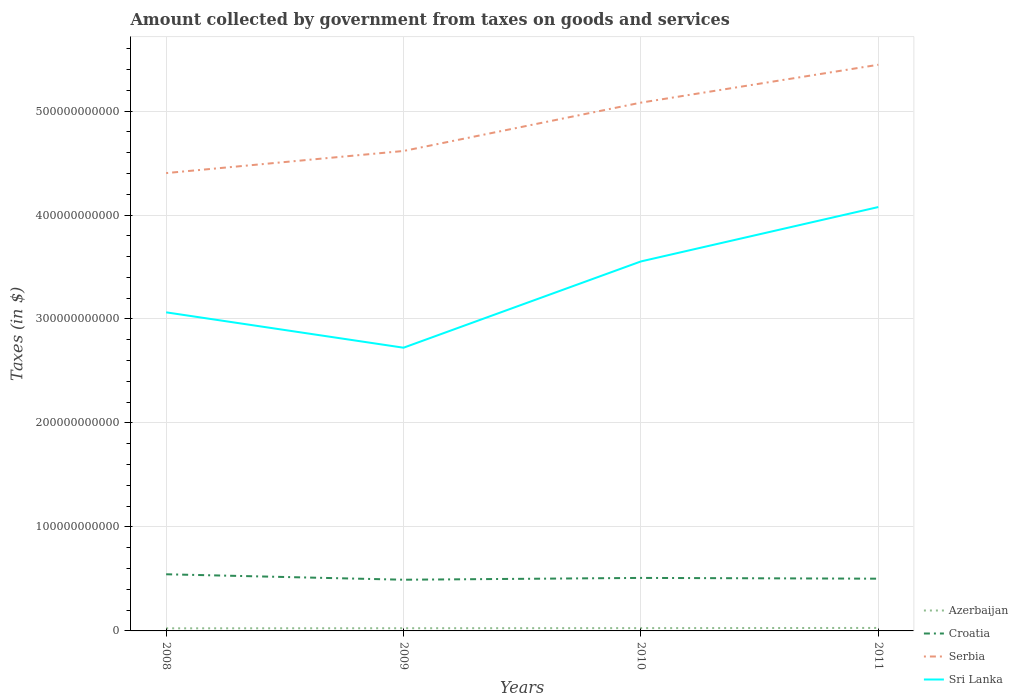How many different coloured lines are there?
Provide a succinct answer. 4. Is the number of lines equal to the number of legend labels?
Offer a terse response. Yes. Across all years, what is the maximum amount collected by government from taxes on goods and services in Croatia?
Ensure brevity in your answer.  4.92e+1. What is the total amount collected by government from taxes on goods and services in Sri Lanka in the graph?
Your answer should be compact. -1.01e+11. What is the difference between the highest and the second highest amount collected by government from taxes on goods and services in Sri Lanka?
Your answer should be very brief. 1.35e+11. Is the amount collected by government from taxes on goods and services in Serbia strictly greater than the amount collected by government from taxes on goods and services in Croatia over the years?
Provide a short and direct response. No. How many lines are there?
Ensure brevity in your answer.  4. How many years are there in the graph?
Provide a succinct answer. 4. What is the difference between two consecutive major ticks on the Y-axis?
Your answer should be compact. 1.00e+11. Are the values on the major ticks of Y-axis written in scientific E-notation?
Your answer should be very brief. No. Does the graph contain any zero values?
Make the answer very short. No. Where does the legend appear in the graph?
Give a very brief answer. Bottom right. How many legend labels are there?
Make the answer very short. 4. What is the title of the graph?
Your answer should be very brief. Amount collected by government from taxes on goods and services. Does "Somalia" appear as one of the legend labels in the graph?
Offer a very short reply. No. What is the label or title of the Y-axis?
Keep it short and to the point. Taxes (in $). What is the Taxes (in $) of Azerbaijan in 2008?
Your response must be concise. 2.50e+09. What is the Taxes (in $) in Croatia in 2008?
Provide a succinct answer. 5.45e+1. What is the Taxes (in $) in Serbia in 2008?
Keep it short and to the point. 4.40e+11. What is the Taxes (in $) in Sri Lanka in 2008?
Your response must be concise. 3.06e+11. What is the Taxes (in $) in Azerbaijan in 2009?
Your response must be concise. 2.59e+09. What is the Taxes (in $) in Croatia in 2009?
Make the answer very short. 4.92e+1. What is the Taxes (in $) of Serbia in 2009?
Provide a short and direct response. 4.62e+11. What is the Taxes (in $) of Sri Lanka in 2009?
Make the answer very short. 2.72e+11. What is the Taxes (in $) of Azerbaijan in 2010?
Provide a succinct answer. 2.70e+09. What is the Taxes (in $) of Croatia in 2010?
Provide a short and direct response. 5.10e+1. What is the Taxes (in $) of Serbia in 2010?
Your response must be concise. 5.08e+11. What is the Taxes (in $) of Sri Lanka in 2010?
Your answer should be very brief. 3.55e+11. What is the Taxes (in $) of Azerbaijan in 2011?
Offer a terse response. 2.87e+09. What is the Taxes (in $) of Croatia in 2011?
Offer a terse response. 5.02e+1. What is the Taxes (in $) in Serbia in 2011?
Provide a succinct answer. 5.45e+11. What is the Taxes (in $) in Sri Lanka in 2011?
Provide a succinct answer. 4.08e+11. Across all years, what is the maximum Taxes (in $) in Azerbaijan?
Your response must be concise. 2.87e+09. Across all years, what is the maximum Taxes (in $) in Croatia?
Offer a very short reply. 5.45e+1. Across all years, what is the maximum Taxes (in $) in Serbia?
Give a very brief answer. 5.45e+11. Across all years, what is the maximum Taxes (in $) in Sri Lanka?
Offer a very short reply. 4.08e+11. Across all years, what is the minimum Taxes (in $) of Azerbaijan?
Keep it short and to the point. 2.50e+09. Across all years, what is the minimum Taxes (in $) in Croatia?
Offer a very short reply. 4.92e+1. Across all years, what is the minimum Taxes (in $) of Serbia?
Your answer should be compact. 4.40e+11. Across all years, what is the minimum Taxes (in $) in Sri Lanka?
Provide a short and direct response. 2.72e+11. What is the total Taxes (in $) of Azerbaijan in the graph?
Make the answer very short. 1.07e+1. What is the total Taxes (in $) in Croatia in the graph?
Give a very brief answer. 2.05e+11. What is the total Taxes (in $) of Serbia in the graph?
Provide a short and direct response. 1.95e+12. What is the total Taxes (in $) of Sri Lanka in the graph?
Your answer should be very brief. 1.34e+12. What is the difference between the Taxes (in $) in Azerbaijan in 2008 and that in 2009?
Give a very brief answer. -9.02e+07. What is the difference between the Taxes (in $) in Croatia in 2008 and that in 2009?
Ensure brevity in your answer.  5.24e+09. What is the difference between the Taxes (in $) in Serbia in 2008 and that in 2009?
Keep it short and to the point. -2.13e+1. What is the difference between the Taxes (in $) of Sri Lanka in 2008 and that in 2009?
Make the answer very short. 3.40e+1. What is the difference between the Taxes (in $) in Azerbaijan in 2008 and that in 2010?
Ensure brevity in your answer.  -1.93e+08. What is the difference between the Taxes (in $) in Croatia in 2008 and that in 2010?
Give a very brief answer. 3.50e+09. What is the difference between the Taxes (in $) in Serbia in 2008 and that in 2010?
Provide a short and direct response. -6.78e+1. What is the difference between the Taxes (in $) in Sri Lanka in 2008 and that in 2010?
Provide a succinct answer. -4.90e+1. What is the difference between the Taxes (in $) of Azerbaijan in 2008 and that in 2011?
Offer a very short reply. -3.62e+08. What is the difference between the Taxes (in $) of Croatia in 2008 and that in 2011?
Provide a succinct answer. 4.24e+09. What is the difference between the Taxes (in $) in Serbia in 2008 and that in 2011?
Offer a very short reply. -1.04e+11. What is the difference between the Taxes (in $) in Sri Lanka in 2008 and that in 2011?
Your answer should be compact. -1.01e+11. What is the difference between the Taxes (in $) of Azerbaijan in 2009 and that in 2010?
Offer a terse response. -1.03e+08. What is the difference between the Taxes (in $) of Croatia in 2009 and that in 2010?
Offer a very short reply. -1.74e+09. What is the difference between the Taxes (in $) in Serbia in 2009 and that in 2010?
Ensure brevity in your answer.  -4.65e+1. What is the difference between the Taxes (in $) of Sri Lanka in 2009 and that in 2010?
Ensure brevity in your answer.  -8.30e+1. What is the difference between the Taxes (in $) in Azerbaijan in 2009 and that in 2011?
Your response must be concise. -2.72e+08. What is the difference between the Taxes (in $) of Croatia in 2009 and that in 2011?
Make the answer very short. -1.01e+09. What is the difference between the Taxes (in $) in Serbia in 2009 and that in 2011?
Offer a very short reply. -8.29e+1. What is the difference between the Taxes (in $) of Sri Lanka in 2009 and that in 2011?
Keep it short and to the point. -1.35e+11. What is the difference between the Taxes (in $) of Azerbaijan in 2010 and that in 2011?
Your answer should be very brief. -1.70e+08. What is the difference between the Taxes (in $) in Croatia in 2010 and that in 2011?
Provide a succinct answer. 7.36e+08. What is the difference between the Taxes (in $) of Serbia in 2010 and that in 2011?
Offer a terse response. -3.64e+1. What is the difference between the Taxes (in $) in Sri Lanka in 2010 and that in 2011?
Your answer should be very brief. -5.23e+1. What is the difference between the Taxes (in $) in Azerbaijan in 2008 and the Taxes (in $) in Croatia in 2009?
Your answer should be compact. -4.67e+1. What is the difference between the Taxes (in $) in Azerbaijan in 2008 and the Taxes (in $) in Serbia in 2009?
Your response must be concise. -4.59e+11. What is the difference between the Taxes (in $) of Azerbaijan in 2008 and the Taxes (in $) of Sri Lanka in 2009?
Keep it short and to the point. -2.70e+11. What is the difference between the Taxes (in $) of Croatia in 2008 and the Taxes (in $) of Serbia in 2009?
Keep it short and to the point. -4.07e+11. What is the difference between the Taxes (in $) of Croatia in 2008 and the Taxes (in $) of Sri Lanka in 2009?
Make the answer very short. -2.18e+11. What is the difference between the Taxes (in $) in Serbia in 2008 and the Taxes (in $) in Sri Lanka in 2009?
Give a very brief answer. 1.68e+11. What is the difference between the Taxes (in $) of Azerbaijan in 2008 and the Taxes (in $) of Croatia in 2010?
Make the answer very short. -4.85e+1. What is the difference between the Taxes (in $) in Azerbaijan in 2008 and the Taxes (in $) in Serbia in 2010?
Offer a terse response. -5.06e+11. What is the difference between the Taxes (in $) of Azerbaijan in 2008 and the Taxes (in $) of Sri Lanka in 2010?
Give a very brief answer. -3.53e+11. What is the difference between the Taxes (in $) of Croatia in 2008 and the Taxes (in $) of Serbia in 2010?
Ensure brevity in your answer.  -4.54e+11. What is the difference between the Taxes (in $) of Croatia in 2008 and the Taxes (in $) of Sri Lanka in 2010?
Your response must be concise. -3.01e+11. What is the difference between the Taxes (in $) of Serbia in 2008 and the Taxes (in $) of Sri Lanka in 2010?
Give a very brief answer. 8.50e+1. What is the difference between the Taxes (in $) in Azerbaijan in 2008 and the Taxes (in $) in Croatia in 2011?
Your answer should be very brief. -4.77e+1. What is the difference between the Taxes (in $) in Azerbaijan in 2008 and the Taxes (in $) in Serbia in 2011?
Provide a succinct answer. -5.42e+11. What is the difference between the Taxes (in $) in Azerbaijan in 2008 and the Taxes (in $) in Sri Lanka in 2011?
Provide a succinct answer. -4.05e+11. What is the difference between the Taxes (in $) in Croatia in 2008 and the Taxes (in $) in Serbia in 2011?
Give a very brief answer. -4.90e+11. What is the difference between the Taxes (in $) of Croatia in 2008 and the Taxes (in $) of Sri Lanka in 2011?
Your answer should be compact. -3.53e+11. What is the difference between the Taxes (in $) of Serbia in 2008 and the Taxes (in $) of Sri Lanka in 2011?
Your answer should be very brief. 3.27e+1. What is the difference between the Taxes (in $) in Azerbaijan in 2009 and the Taxes (in $) in Croatia in 2010?
Keep it short and to the point. -4.84e+1. What is the difference between the Taxes (in $) in Azerbaijan in 2009 and the Taxes (in $) in Serbia in 2010?
Make the answer very short. -5.06e+11. What is the difference between the Taxes (in $) in Azerbaijan in 2009 and the Taxes (in $) in Sri Lanka in 2010?
Provide a succinct answer. -3.53e+11. What is the difference between the Taxes (in $) in Croatia in 2009 and the Taxes (in $) in Serbia in 2010?
Give a very brief answer. -4.59e+11. What is the difference between the Taxes (in $) of Croatia in 2009 and the Taxes (in $) of Sri Lanka in 2010?
Keep it short and to the point. -3.06e+11. What is the difference between the Taxes (in $) in Serbia in 2009 and the Taxes (in $) in Sri Lanka in 2010?
Offer a very short reply. 1.06e+11. What is the difference between the Taxes (in $) in Azerbaijan in 2009 and the Taxes (in $) in Croatia in 2011?
Your answer should be very brief. -4.77e+1. What is the difference between the Taxes (in $) in Azerbaijan in 2009 and the Taxes (in $) in Serbia in 2011?
Offer a very short reply. -5.42e+11. What is the difference between the Taxes (in $) of Azerbaijan in 2009 and the Taxes (in $) of Sri Lanka in 2011?
Your answer should be compact. -4.05e+11. What is the difference between the Taxes (in $) in Croatia in 2009 and the Taxes (in $) in Serbia in 2011?
Offer a very short reply. -4.95e+11. What is the difference between the Taxes (in $) in Croatia in 2009 and the Taxes (in $) in Sri Lanka in 2011?
Keep it short and to the point. -3.58e+11. What is the difference between the Taxes (in $) in Serbia in 2009 and the Taxes (in $) in Sri Lanka in 2011?
Ensure brevity in your answer.  5.39e+1. What is the difference between the Taxes (in $) in Azerbaijan in 2010 and the Taxes (in $) in Croatia in 2011?
Make the answer very short. -4.75e+1. What is the difference between the Taxes (in $) of Azerbaijan in 2010 and the Taxes (in $) of Serbia in 2011?
Your answer should be very brief. -5.42e+11. What is the difference between the Taxes (in $) of Azerbaijan in 2010 and the Taxes (in $) of Sri Lanka in 2011?
Provide a short and direct response. -4.05e+11. What is the difference between the Taxes (in $) of Croatia in 2010 and the Taxes (in $) of Serbia in 2011?
Ensure brevity in your answer.  -4.94e+11. What is the difference between the Taxes (in $) in Croatia in 2010 and the Taxes (in $) in Sri Lanka in 2011?
Provide a succinct answer. -3.57e+11. What is the difference between the Taxes (in $) of Serbia in 2010 and the Taxes (in $) of Sri Lanka in 2011?
Make the answer very short. 1.00e+11. What is the average Taxes (in $) in Azerbaijan per year?
Your answer should be compact. 2.66e+09. What is the average Taxes (in $) in Croatia per year?
Your response must be concise. 5.12e+1. What is the average Taxes (in $) of Serbia per year?
Offer a terse response. 4.89e+11. What is the average Taxes (in $) of Sri Lanka per year?
Offer a very short reply. 3.35e+11. In the year 2008, what is the difference between the Taxes (in $) in Azerbaijan and Taxes (in $) in Croatia?
Your answer should be compact. -5.20e+1. In the year 2008, what is the difference between the Taxes (in $) in Azerbaijan and Taxes (in $) in Serbia?
Keep it short and to the point. -4.38e+11. In the year 2008, what is the difference between the Taxes (in $) in Azerbaijan and Taxes (in $) in Sri Lanka?
Offer a very short reply. -3.04e+11. In the year 2008, what is the difference between the Taxes (in $) of Croatia and Taxes (in $) of Serbia?
Give a very brief answer. -3.86e+11. In the year 2008, what is the difference between the Taxes (in $) of Croatia and Taxes (in $) of Sri Lanka?
Your answer should be very brief. -2.52e+11. In the year 2008, what is the difference between the Taxes (in $) in Serbia and Taxes (in $) in Sri Lanka?
Provide a short and direct response. 1.34e+11. In the year 2009, what is the difference between the Taxes (in $) of Azerbaijan and Taxes (in $) of Croatia?
Keep it short and to the point. -4.66e+1. In the year 2009, what is the difference between the Taxes (in $) in Azerbaijan and Taxes (in $) in Serbia?
Offer a terse response. -4.59e+11. In the year 2009, what is the difference between the Taxes (in $) of Azerbaijan and Taxes (in $) of Sri Lanka?
Your response must be concise. -2.70e+11. In the year 2009, what is the difference between the Taxes (in $) of Croatia and Taxes (in $) of Serbia?
Your answer should be compact. -4.12e+11. In the year 2009, what is the difference between the Taxes (in $) of Croatia and Taxes (in $) of Sri Lanka?
Your response must be concise. -2.23e+11. In the year 2009, what is the difference between the Taxes (in $) in Serbia and Taxes (in $) in Sri Lanka?
Your response must be concise. 1.89e+11. In the year 2010, what is the difference between the Taxes (in $) of Azerbaijan and Taxes (in $) of Croatia?
Provide a short and direct response. -4.83e+1. In the year 2010, what is the difference between the Taxes (in $) in Azerbaijan and Taxes (in $) in Serbia?
Offer a very short reply. -5.05e+11. In the year 2010, what is the difference between the Taxes (in $) of Azerbaijan and Taxes (in $) of Sri Lanka?
Provide a succinct answer. -3.53e+11. In the year 2010, what is the difference between the Taxes (in $) of Croatia and Taxes (in $) of Serbia?
Make the answer very short. -4.57e+11. In the year 2010, what is the difference between the Taxes (in $) in Croatia and Taxes (in $) in Sri Lanka?
Ensure brevity in your answer.  -3.04e+11. In the year 2010, what is the difference between the Taxes (in $) of Serbia and Taxes (in $) of Sri Lanka?
Your answer should be compact. 1.53e+11. In the year 2011, what is the difference between the Taxes (in $) in Azerbaijan and Taxes (in $) in Croatia?
Provide a succinct answer. -4.74e+1. In the year 2011, what is the difference between the Taxes (in $) in Azerbaijan and Taxes (in $) in Serbia?
Provide a succinct answer. -5.42e+11. In the year 2011, what is the difference between the Taxes (in $) of Azerbaijan and Taxes (in $) of Sri Lanka?
Your answer should be compact. -4.05e+11. In the year 2011, what is the difference between the Taxes (in $) of Croatia and Taxes (in $) of Serbia?
Your answer should be compact. -4.94e+11. In the year 2011, what is the difference between the Taxes (in $) in Croatia and Taxes (in $) in Sri Lanka?
Your answer should be very brief. -3.57e+11. In the year 2011, what is the difference between the Taxes (in $) of Serbia and Taxes (in $) of Sri Lanka?
Offer a terse response. 1.37e+11. What is the ratio of the Taxes (in $) in Azerbaijan in 2008 to that in 2009?
Your answer should be compact. 0.97. What is the ratio of the Taxes (in $) in Croatia in 2008 to that in 2009?
Provide a succinct answer. 1.11. What is the ratio of the Taxes (in $) in Serbia in 2008 to that in 2009?
Your response must be concise. 0.95. What is the ratio of the Taxes (in $) in Sri Lanka in 2008 to that in 2009?
Make the answer very short. 1.12. What is the ratio of the Taxes (in $) of Azerbaijan in 2008 to that in 2010?
Your answer should be very brief. 0.93. What is the ratio of the Taxes (in $) in Croatia in 2008 to that in 2010?
Ensure brevity in your answer.  1.07. What is the ratio of the Taxes (in $) of Serbia in 2008 to that in 2010?
Your response must be concise. 0.87. What is the ratio of the Taxes (in $) of Sri Lanka in 2008 to that in 2010?
Offer a terse response. 0.86. What is the ratio of the Taxes (in $) of Azerbaijan in 2008 to that in 2011?
Provide a succinct answer. 0.87. What is the ratio of the Taxes (in $) in Croatia in 2008 to that in 2011?
Provide a short and direct response. 1.08. What is the ratio of the Taxes (in $) in Serbia in 2008 to that in 2011?
Your response must be concise. 0.81. What is the ratio of the Taxes (in $) of Sri Lanka in 2008 to that in 2011?
Your answer should be very brief. 0.75. What is the ratio of the Taxes (in $) of Azerbaijan in 2009 to that in 2010?
Provide a short and direct response. 0.96. What is the ratio of the Taxes (in $) in Croatia in 2009 to that in 2010?
Your response must be concise. 0.97. What is the ratio of the Taxes (in $) in Serbia in 2009 to that in 2010?
Your answer should be compact. 0.91. What is the ratio of the Taxes (in $) of Sri Lanka in 2009 to that in 2010?
Give a very brief answer. 0.77. What is the ratio of the Taxes (in $) of Azerbaijan in 2009 to that in 2011?
Your answer should be compact. 0.91. What is the ratio of the Taxes (in $) in Croatia in 2009 to that in 2011?
Give a very brief answer. 0.98. What is the ratio of the Taxes (in $) of Serbia in 2009 to that in 2011?
Your answer should be compact. 0.85. What is the ratio of the Taxes (in $) of Sri Lanka in 2009 to that in 2011?
Your response must be concise. 0.67. What is the ratio of the Taxes (in $) in Azerbaijan in 2010 to that in 2011?
Offer a very short reply. 0.94. What is the ratio of the Taxes (in $) of Croatia in 2010 to that in 2011?
Provide a short and direct response. 1.01. What is the ratio of the Taxes (in $) of Serbia in 2010 to that in 2011?
Make the answer very short. 0.93. What is the ratio of the Taxes (in $) in Sri Lanka in 2010 to that in 2011?
Offer a very short reply. 0.87. What is the difference between the highest and the second highest Taxes (in $) of Azerbaijan?
Ensure brevity in your answer.  1.70e+08. What is the difference between the highest and the second highest Taxes (in $) of Croatia?
Provide a succinct answer. 3.50e+09. What is the difference between the highest and the second highest Taxes (in $) in Serbia?
Your answer should be compact. 3.64e+1. What is the difference between the highest and the second highest Taxes (in $) of Sri Lanka?
Provide a short and direct response. 5.23e+1. What is the difference between the highest and the lowest Taxes (in $) in Azerbaijan?
Offer a very short reply. 3.62e+08. What is the difference between the highest and the lowest Taxes (in $) in Croatia?
Provide a short and direct response. 5.24e+09. What is the difference between the highest and the lowest Taxes (in $) of Serbia?
Your answer should be compact. 1.04e+11. What is the difference between the highest and the lowest Taxes (in $) of Sri Lanka?
Keep it short and to the point. 1.35e+11. 